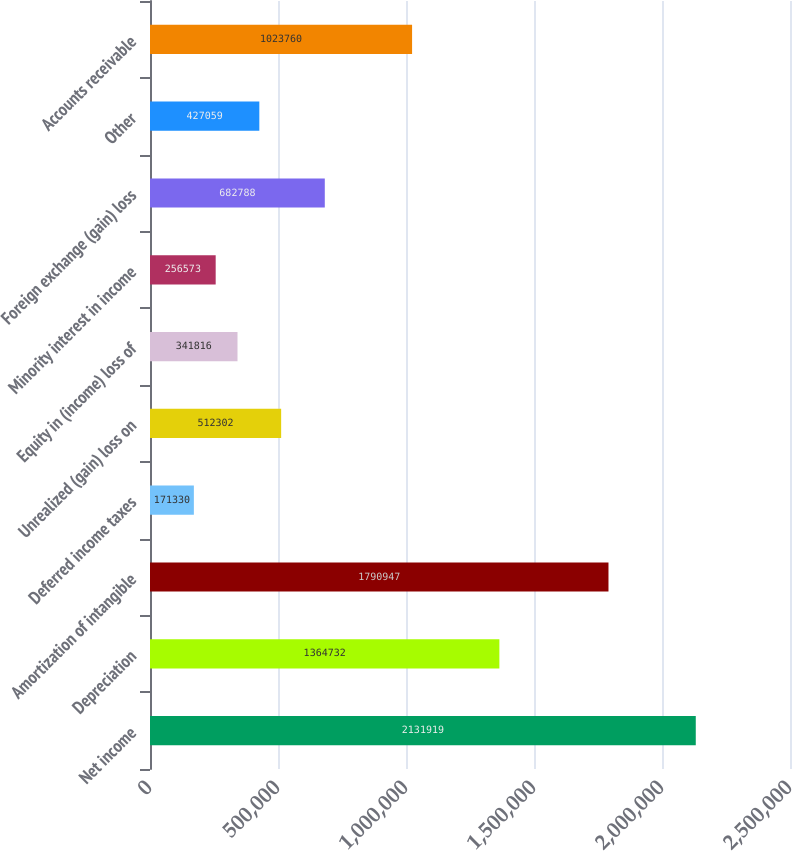Convert chart. <chart><loc_0><loc_0><loc_500><loc_500><bar_chart><fcel>Net income<fcel>Depreciation<fcel>Amortization of intangible<fcel>Deferred income taxes<fcel>Unrealized (gain) loss on<fcel>Equity in (income) loss of<fcel>Minority interest in income<fcel>Foreign exchange (gain) loss<fcel>Other<fcel>Accounts receivable<nl><fcel>2.13192e+06<fcel>1.36473e+06<fcel>1.79095e+06<fcel>171330<fcel>512302<fcel>341816<fcel>256573<fcel>682788<fcel>427059<fcel>1.02376e+06<nl></chart> 